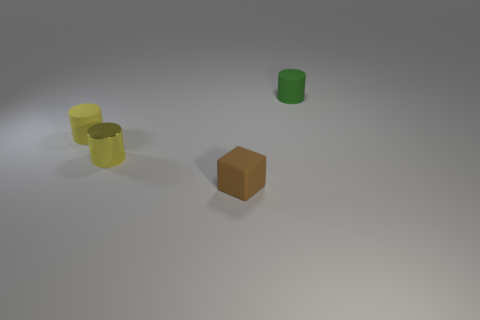Which objects in the image have a similar color? The two cylindrical objects share a similar hue of yellow and green, suggesting a color scheme that connects them. 